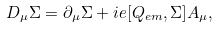<formula> <loc_0><loc_0><loc_500><loc_500>D _ { \mu } \Sigma = \partial _ { \mu } \Sigma + i e [ Q _ { e m } , \Sigma ] A _ { \mu } ,</formula> 